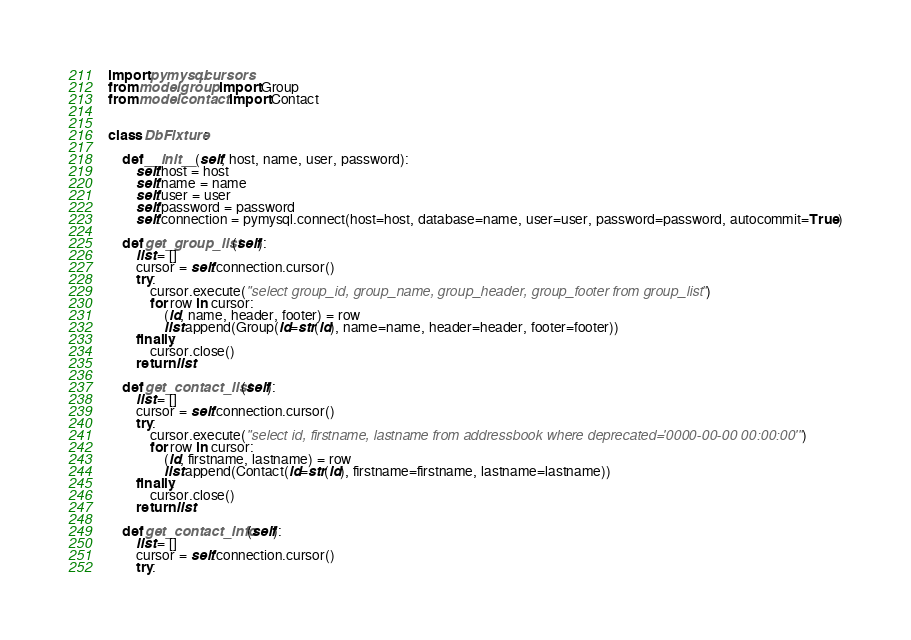Convert code to text. <code><loc_0><loc_0><loc_500><loc_500><_Python_>import pymysql.cursors
from model.group import Group
from model.contact import Contact


class DbFixture:

    def __init__(self, host, name, user, password):
        self.host = host
        self.name = name
        self.user = user
        self.password = password
        self.connection = pymysql.connect(host=host, database=name, user=user, password=password, autocommit=True)

    def get_group_list(self):
        list = []
        cursor = self.connection.cursor()
        try:
            cursor.execute("select group_id, group_name, group_header, group_footer from group_list")
            for row in cursor:
                (id, name, header, footer) = row
                list.append(Group(id=str(id), name=name, header=header, footer=footer))
        finally:
            cursor.close()
        return list

    def get_contact_list(self):
        list = []
        cursor = self.connection.cursor()
        try:
            cursor.execute("select id, firstname, lastname from addressbook where deprecated='0000-00-00 00:00:00'")
            for row in cursor:
                (id, firstname, lastname) = row
                list.append(Contact(id=str(id), firstname=firstname, lastname=lastname))
        finally:
            cursor.close()
        return list

    def get_contact_info(self):
        list = []
        cursor = self.connection.cursor()
        try:</code> 